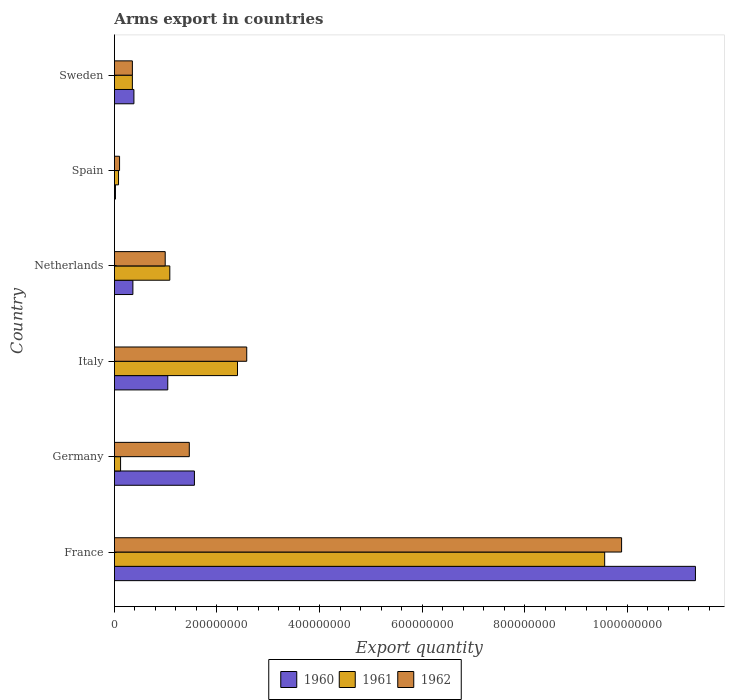How many different coloured bars are there?
Make the answer very short. 3. Are the number of bars on each tick of the Y-axis equal?
Your response must be concise. Yes. How many bars are there on the 3rd tick from the top?
Your answer should be compact. 3. How many bars are there on the 5th tick from the bottom?
Give a very brief answer. 3. In how many cases, is the number of bars for a given country not equal to the number of legend labels?
Provide a succinct answer. 0. What is the total arms export in 1961 in France?
Offer a terse response. 9.56e+08. Across all countries, what is the maximum total arms export in 1960?
Keep it short and to the point. 1.13e+09. Across all countries, what is the minimum total arms export in 1960?
Ensure brevity in your answer.  2.00e+06. In which country was the total arms export in 1962 minimum?
Offer a very short reply. Spain. What is the total total arms export in 1961 in the graph?
Your answer should be very brief. 1.36e+09. What is the difference between the total arms export in 1960 in France and that in Spain?
Offer a terse response. 1.13e+09. What is the difference between the total arms export in 1960 in Germany and the total arms export in 1961 in Sweden?
Provide a succinct answer. 1.21e+08. What is the average total arms export in 1962 per country?
Your answer should be compact. 2.56e+08. What is the difference between the total arms export in 1961 and total arms export in 1962 in France?
Offer a very short reply. -3.30e+07. In how many countries, is the total arms export in 1961 greater than 800000000 ?
Make the answer very short. 1. What is the ratio of the total arms export in 1962 in France to that in Netherlands?
Provide a succinct answer. 9.99. Is the difference between the total arms export in 1961 in France and Sweden greater than the difference between the total arms export in 1962 in France and Sweden?
Give a very brief answer. No. What is the difference between the highest and the second highest total arms export in 1961?
Your answer should be very brief. 7.16e+08. What is the difference between the highest and the lowest total arms export in 1962?
Make the answer very short. 9.79e+08. What does the 2nd bar from the top in Netherlands represents?
Offer a terse response. 1961. Are all the bars in the graph horizontal?
Provide a short and direct response. Yes. Are the values on the major ticks of X-axis written in scientific E-notation?
Make the answer very short. No. Does the graph contain any zero values?
Provide a short and direct response. No. Does the graph contain grids?
Give a very brief answer. No. Where does the legend appear in the graph?
Your answer should be very brief. Bottom center. How many legend labels are there?
Give a very brief answer. 3. What is the title of the graph?
Keep it short and to the point. Arms export in countries. What is the label or title of the X-axis?
Ensure brevity in your answer.  Export quantity. What is the label or title of the Y-axis?
Provide a short and direct response. Country. What is the Export quantity of 1960 in France?
Your response must be concise. 1.13e+09. What is the Export quantity in 1961 in France?
Offer a terse response. 9.56e+08. What is the Export quantity of 1962 in France?
Offer a terse response. 9.89e+08. What is the Export quantity in 1960 in Germany?
Make the answer very short. 1.56e+08. What is the Export quantity of 1961 in Germany?
Provide a short and direct response. 1.20e+07. What is the Export quantity of 1962 in Germany?
Your response must be concise. 1.46e+08. What is the Export quantity in 1960 in Italy?
Your answer should be compact. 1.04e+08. What is the Export quantity of 1961 in Italy?
Offer a terse response. 2.40e+08. What is the Export quantity in 1962 in Italy?
Make the answer very short. 2.58e+08. What is the Export quantity of 1960 in Netherlands?
Ensure brevity in your answer.  3.60e+07. What is the Export quantity in 1961 in Netherlands?
Your answer should be very brief. 1.08e+08. What is the Export quantity in 1962 in Netherlands?
Offer a very short reply. 9.90e+07. What is the Export quantity of 1960 in Spain?
Ensure brevity in your answer.  2.00e+06. What is the Export quantity of 1961 in Spain?
Your response must be concise. 8.00e+06. What is the Export quantity of 1962 in Spain?
Ensure brevity in your answer.  1.00e+07. What is the Export quantity in 1960 in Sweden?
Offer a terse response. 3.80e+07. What is the Export quantity in 1961 in Sweden?
Offer a terse response. 3.50e+07. What is the Export quantity of 1962 in Sweden?
Keep it short and to the point. 3.50e+07. Across all countries, what is the maximum Export quantity in 1960?
Your answer should be compact. 1.13e+09. Across all countries, what is the maximum Export quantity of 1961?
Provide a short and direct response. 9.56e+08. Across all countries, what is the maximum Export quantity in 1962?
Provide a short and direct response. 9.89e+08. Across all countries, what is the minimum Export quantity in 1960?
Provide a short and direct response. 2.00e+06. Across all countries, what is the minimum Export quantity of 1961?
Your answer should be compact. 8.00e+06. Across all countries, what is the minimum Export quantity in 1962?
Give a very brief answer. 1.00e+07. What is the total Export quantity in 1960 in the graph?
Provide a short and direct response. 1.47e+09. What is the total Export quantity of 1961 in the graph?
Offer a terse response. 1.36e+09. What is the total Export quantity of 1962 in the graph?
Provide a succinct answer. 1.54e+09. What is the difference between the Export quantity of 1960 in France and that in Germany?
Your answer should be compact. 9.77e+08. What is the difference between the Export quantity in 1961 in France and that in Germany?
Make the answer very short. 9.44e+08. What is the difference between the Export quantity in 1962 in France and that in Germany?
Ensure brevity in your answer.  8.43e+08. What is the difference between the Export quantity in 1960 in France and that in Italy?
Your answer should be very brief. 1.03e+09. What is the difference between the Export quantity in 1961 in France and that in Italy?
Provide a short and direct response. 7.16e+08. What is the difference between the Export quantity of 1962 in France and that in Italy?
Your response must be concise. 7.31e+08. What is the difference between the Export quantity of 1960 in France and that in Netherlands?
Provide a short and direct response. 1.10e+09. What is the difference between the Export quantity of 1961 in France and that in Netherlands?
Your answer should be very brief. 8.48e+08. What is the difference between the Export quantity of 1962 in France and that in Netherlands?
Your response must be concise. 8.90e+08. What is the difference between the Export quantity in 1960 in France and that in Spain?
Make the answer very short. 1.13e+09. What is the difference between the Export quantity of 1961 in France and that in Spain?
Give a very brief answer. 9.48e+08. What is the difference between the Export quantity of 1962 in France and that in Spain?
Your answer should be compact. 9.79e+08. What is the difference between the Export quantity of 1960 in France and that in Sweden?
Provide a succinct answer. 1.10e+09. What is the difference between the Export quantity in 1961 in France and that in Sweden?
Give a very brief answer. 9.21e+08. What is the difference between the Export quantity in 1962 in France and that in Sweden?
Ensure brevity in your answer.  9.54e+08. What is the difference between the Export quantity of 1960 in Germany and that in Italy?
Give a very brief answer. 5.20e+07. What is the difference between the Export quantity of 1961 in Germany and that in Italy?
Your response must be concise. -2.28e+08. What is the difference between the Export quantity in 1962 in Germany and that in Italy?
Make the answer very short. -1.12e+08. What is the difference between the Export quantity in 1960 in Germany and that in Netherlands?
Make the answer very short. 1.20e+08. What is the difference between the Export quantity of 1961 in Germany and that in Netherlands?
Provide a short and direct response. -9.60e+07. What is the difference between the Export quantity in 1962 in Germany and that in Netherlands?
Your answer should be very brief. 4.70e+07. What is the difference between the Export quantity of 1960 in Germany and that in Spain?
Your response must be concise. 1.54e+08. What is the difference between the Export quantity of 1961 in Germany and that in Spain?
Give a very brief answer. 4.00e+06. What is the difference between the Export quantity of 1962 in Germany and that in Spain?
Keep it short and to the point. 1.36e+08. What is the difference between the Export quantity in 1960 in Germany and that in Sweden?
Your response must be concise. 1.18e+08. What is the difference between the Export quantity in 1961 in Germany and that in Sweden?
Offer a very short reply. -2.30e+07. What is the difference between the Export quantity of 1962 in Germany and that in Sweden?
Your answer should be very brief. 1.11e+08. What is the difference between the Export quantity in 1960 in Italy and that in Netherlands?
Your response must be concise. 6.80e+07. What is the difference between the Export quantity in 1961 in Italy and that in Netherlands?
Provide a short and direct response. 1.32e+08. What is the difference between the Export quantity in 1962 in Italy and that in Netherlands?
Your response must be concise. 1.59e+08. What is the difference between the Export quantity in 1960 in Italy and that in Spain?
Ensure brevity in your answer.  1.02e+08. What is the difference between the Export quantity in 1961 in Italy and that in Spain?
Make the answer very short. 2.32e+08. What is the difference between the Export quantity of 1962 in Italy and that in Spain?
Your answer should be very brief. 2.48e+08. What is the difference between the Export quantity in 1960 in Italy and that in Sweden?
Your answer should be compact. 6.60e+07. What is the difference between the Export quantity in 1961 in Italy and that in Sweden?
Your answer should be compact. 2.05e+08. What is the difference between the Export quantity of 1962 in Italy and that in Sweden?
Provide a succinct answer. 2.23e+08. What is the difference between the Export quantity of 1960 in Netherlands and that in Spain?
Keep it short and to the point. 3.40e+07. What is the difference between the Export quantity in 1962 in Netherlands and that in Spain?
Offer a terse response. 8.90e+07. What is the difference between the Export quantity of 1960 in Netherlands and that in Sweden?
Your response must be concise. -2.00e+06. What is the difference between the Export quantity of 1961 in Netherlands and that in Sweden?
Make the answer very short. 7.30e+07. What is the difference between the Export quantity of 1962 in Netherlands and that in Sweden?
Your response must be concise. 6.40e+07. What is the difference between the Export quantity in 1960 in Spain and that in Sweden?
Give a very brief answer. -3.60e+07. What is the difference between the Export quantity in 1961 in Spain and that in Sweden?
Keep it short and to the point. -2.70e+07. What is the difference between the Export quantity in 1962 in Spain and that in Sweden?
Your answer should be compact. -2.50e+07. What is the difference between the Export quantity in 1960 in France and the Export quantity in 1961 in Germany?
Your answer should be very brief. 1.12e+09. What is the difference between the Export quantity of 1960 in France and the Export quantity of 1962 in Germany?
Your answer should be very brief. 9.87e+08. What is the difference between the Export quantity in 1961 in France and the Export quantity in 1962 in Germany?
Your answer should be compact. 8.10e+08. What is the difference between the Export quantity in 1960 in France and the Export quantity in 1961 in Italy?
Provide a short and direct response. 8.93e+08. What is the difference between the Export quantity in 1960 in France and the Export quantity in 1962 in Italy?
Your response must be concise. 8.75e+08. What is the difference between the Export quantity of 1961 in France and the Export quantity of 1962 in Italy?
Offer a very short reply. 6.98e+08. What is the difference between the Export quantity in 1960 in France and the Export quantity in 1961 in Netherlands?
Offer a very short reply. 1.02e+09. What is the difference between the Export quantity of 1960 in France and the Export quantity of 1962 in Netherlands?
Give a very brief answer. 1.03e+09. What is the difference between the Export quantity in 1961 in France and the Export quantity in 1962 in Netherlands?
Give a very brief answer. 8.57e+08. What is the difference between the Export quantity in 1960 in France and the Export quantity in 1961 in Spain?
Your answer should be compact. 1.12e+09. What is the difference between the Export quantity in 1960 in France and the Export quantity in 1962 in Spain?
Ensure brevity in your answer.  1.12e+09. What is the difference between the Export quantity in 1961 in France and the Export quantity in 1962 in Spain?
Your response must be concise. 9.46e+08. What is the difference between the Export quantity of 1960 in France and the Export quantity of 1961 in Sweden?
Keep it short and to the point. 1.10e+09. What is the difference between the Export quantity of 1960 in France and the Export quantity of 1962 in Sweden?
Your answer should be compact. 1.10e+09. What is the difference between the Export quantity of 1961 in France and the Export quantity of 1962 in Sweden?
Provide a short and direct response. 9.21e+08. What is the difference between the Export quantity of 1960 in Germany and the Export quantity of 1961 in Italy?
Your answer should be compact. -8.40e+07. What is the difference between the Export quantity of 1960 in Germany and the Export quantity of 1962 in Italy?
Give a very brief answer. -1.02e+08. What is the difference between the Export quantity in 1961 in Germany and the Export quantity in 1962 in Italy?
Keep it short and to the point. -2.46e+08. What is the difference between the Export quantity in 1960 in Germany and the Export quantity in 1961 in Netherlands?
Keep it short and to the point. 4.80e+07. What is the difference between the Export quantity in 1960 in Germany and the Export quantity in 1962 in Netherlands?
Offer a terse response. 5.70e+07. What is the difference between the Export quantity in 1961 in Germany and the Export quantity in 1962 in Netherlands?
Ensure brevity in your answer.  -8.70e+07. What is the difference between the Export quantity in 1960 in Germany and the Export quantity in 1961 in Spain?
Your answer should be compact. 1.48e+08. What is the difference between the Export quantity in 1960 in Germany and the Export quantity in 1962 in Spain?
Provide a short and direct response. 1.46e+08. What is the difference between the Export quantity in 1960 in Germany and the Export quantity in 1961 in Sweden?
Your answer should be very brief. 1.21e+08. What is the difference between the Export quantity in 1960 in Germany and the Export quantity in 1962 in Sweden?
Ensure brevity in your answer.  1.21e+08. What is the difference between the Export quantity in 1961 in Germany and the Export quantity in 1962 in Sweden?
Offer a very short reply. -2.30e+07. What is the difference between the Export quantity of 1960 in Italy and the Export quantity of 1961 in Netherlands?
Your response must be concise. -4.00e+06. What is the difference between the Export quantity of 1961 in Italy and the Export quantity of 1962 in Netherlands?
Ensure brevity in your answer.  1.41e+08. What is the difference between the Export quantity of 1960 in Italy and the Export quantity of 1961 in Spain?
Make the answer very short. 9.60e+07. What is the difference between the Export quantity of 1960 in Italy and the Export quantity of 1962 in Spain?
Your answer should be compact. 9.40e+07. What is the difference between the Export quantity in 1961 in Italy and the Export quantity in 1962 in Spain?
Ensure brevity in your answer.  2.30e+08. What is the difference between the Export quantity of 1960 in Italy and the Export quantity of 1961 in Sweden?
Make the answer very short. 6.90e+07. What is the difference between the Export quantity in 1960 in Italy and the Export quantity in 1962 in Sweden?
Offer a very short reply. 6.90e+07. What is the difference between the Export quantity in 1961 in Italy and the Export quantity in 1962 in Sweden?
Offer a very short reply. 2.05e+08. What is the difference between the Export quantity in 1960 in Netherlands and the Export quantity in 1961 in Spain?
Offer a very short reply. 2.80e+07. What is the difference between the Export quantity in 1960 in Netherlands and the Export quantity in 1962 in Spain?
Your answer should be very brief. 2.60e+07. What is the difference between the Export quantity in 1961 in Netherlands and the Export quantity in 1962 in Spain?
Provide a succinct answer. 9.80e+07. What is the difference between the Export quantity in 1960 in Netherlands and the Export quantity in 1961 in Sweden?
Keep it short and to the point. 1.00e+06. What is the difference between the Export quantity of 1961 in Netherlands and the Export quantity of 1962 in Sweden?
Keep it short and to the point. 7.30e+07. What is the difference between the Export quantity in 1960 in Spain and the Export quantity in 1961 in Sweden?
Make the answer very short. -3.30e+07. What is the difference between the Export quantity of 1960 in Spain and the Export quantity of 1962 in Sweden?
Your response must be concise. -3.30e+07. What is the difference between the Export quantity of 1961 in Spain and the Export quantity of 1962 in Sweden?
Provide a short and direct response. -2.70e+07. What is the average Export quantity in 1960 per country?
Provide a short and direct response. 2.45e+08. What is the average Export quantity of 1961 per country?
Your answer should be compact. 2.26e+08. What is the average Export quantity in 1962 per country?
Offer a very short reply. 2.56e+08. What is the difference between the Export quantity in 1960 and Export quantity in 1961 in France?
Your response must be concise. 1.77e+08. What is the difference between the Export quantity in 1960 and Export quantity in 1962 in France?
Ensure brevity in your answer.  1.44e+08. What is the difference between the Export quantity in 1961 and Export quantity in 1962 in France?
Your answer should be compact. -3.30e+07. What is the difference between the Export quantity of 1960 and Export quantity of 1961 in Germany?
Ensure brevity in your answer.  1.44e+08. What is the difference between the Export quantity of 1961 and Export quantity of 1962 in Germany?
Make the answer very short. -1.34e+08. What is the difference between the Export quantity in 1960 and Export quantity in 1961 in Italy?
Your response must be concise. -1.36e+08. What is the difference between the Export quantity in 1960 and Export quantity in 1962 in Italy?
Give a very brief answer. -1.54e+08. What is the difference between the Export quantity in 1961 and Export quantity in 1962 in Italy?
Your response must be concise. -1.80e+07. What is the difference between the Export quantity of 1960 and Export quantity of 1961 in Netherlands?
Your response must be concise. -7.20e+07. What is the difference between the Export quantity of 1960 and Export quantity of 1962 in Netherlands?
Your answer should be very brief. -6.30e+07. What is the difference between the Export quantity of 1961 and Export quantity of 1962 in Netherlands?
Offer a very short reply. 9.00e+06. What is the difference between the Export quantity of 1960 and Export quantity of 1961 in Spain?
Keep it short and to the point. -6.00e+06. What is the difference between the Export quantity of 1960 and Export quantity of 1962 in Spain?
Offer a terse response. -8.00e+06. What is the difference between the Export quantity of 1960 and Export quantity of 1961 in Sweden?
Provide a succinct answer. 3.00e+06. What is the difference between the Export quantity in 1960 and Export quantity in 1962 in Sweden?
Ensure brevity in your answer.  3.00e+06. What is the difference between the Export quantity in 1961 and Export quantity in 1962 in Sweden?
Provide a short and direct response. 0. What is the ratio of the Export quantity of 1960 in France to that in Germany?
Make the answer very short. 7.26. What is the ratio of the Export quantity of 1961 in France to that in Germany?
Give a very brief answer. 79.67. What is the ratio of the Export quantity in 1962 in France to that in Germany?
Make the answer very short. 6.77. What is the ratio of the Export quantity of 1960 in France to that in Italy?
Ensure brevity in your answer.  10.89. What is the ratio of the Export quantity of 1961 in France to that in Italy?
Provide a succinct answer. 3.98. What is the ratio of the Export quantity of 1962 in France to that in Italy?
Offer a very short reply. 3.83. What is the ratio of the Export quantity of 1960 in France to that in Netherlands?
Your answer should be very brief. 31.47. What is the ratio of the Export quantity of 1961 in France to that in Netherlands?
Your response must be concise. 8.85. What is the ratio of the Export quantity in 1962 in France to that in Netherlands?
Ensure brevity in your answer.  9.99. What is the ratio of the Export quantity in 1960 in France to that in Spain?
Your answer should be very brief. 566.5. What is the ratio of the Export quantity in 1961 in France to that in Spain?
Your answer should be very brief. 119.5. What is the ratio of the Export quantity in 1962 in France to that in Spain?
Keep it short and to the point. 98.9. What is the ratio of the Export quantity in 1960 in France to that in Sweden?
Provide a succinct answer. 29.82. What is the ratio of the Export quantity of 1961 in France to that in Sweden?
Offer a very short reply. 27.31. What is the ratio of the Export quantity of 1962 in France to that in Sweden?
Your answer should be compact. 28.26. What is the ratio of the Export quantity of 1961 in Germany to that in Italy?
Your answer should be very brief. 0.05. What is the ratio of the Export quantity in 1962 in Germany to that in Italy?
Ensure brevity in your answer.  0.57. What is the ratio of the Export quantity of 1960 in Germany to that in Netherlands?
Ensure brevity in your answer.  4.33. What is the ratio of the Export quantity of 1962 in Germany to that in Netherlands?
Keep it short and to the point. 1.47. What is the ratio of the Export quantity in 1960 in Germany to that in Spain?
Give a very brief answer. 78. What is the ratio of the Export quantity of 1962 in Germany to that in Spain?
Keep it short and to the point. 14.6. What is the ratio of the Export quantity in 1960 in Germany to that in Sweden?
Your answer should be compact. 4.11. What is the ratio of the Export quantity of 1961 in Germany to that in Sweden?
Keep it short and to the point. 0.34. What is the ratio of the Export quantity in 1962 in Germany to that in Sweden?
Provide a short and direct response. 4.17. What is the ratio of the Export quantity in 1960 in Italy to that in Netherlands?
Your answer should be very brief. 2.89. What is the ratio of the Export quantity of 1961 in Italy to that in Netherlands?
Your answer should be compact. 2.22. What is the ratio of the Export quantity in 1962 in Italy to that in Netherlands?
Make the answer very short. 2.61. What is the ratio of the Export quantity of 1961 in Italy to that in Spain?
Make the answer very short. 30. What is the ratio of the Export quantity in 1962 in Italy to that in Spain?
Keep it short and to the point. 25.8. What is the ratio of the Export quantity in 1960 in Italy to that in Sweden?
Your answer should be compact. 2.74. What is the ratio of the Export quantity of 1961 in Italy to that in Sweden?
Offer a very short reply. 6.86. What is the ratio of the Export quantity of 1962 in Italy to that in Sweden?
Offer a very short reply. 7.37. What is the ratio of the Export quantity of 1960 in Netherlands to that in Spain?
Offer a very short reply. 18. What is the ratio of the Export quantity of 1961 in Netherlands to that in Sweden?
Offer a very short reply. 3.09. What is the ratio of the Export quantity in 1962 in Netherlands to that in Sweden?
Provide a short and direct response. 2.83. What is the ratio of the Export quantity of 1960 in Spain to that in Sweden?
Make the answer very short. 0.05. What is the ratio of the Export quantity of 1961 in Spain to that in Sweden?
Keep it short and to the point. 0.23. What is the ratio of the Export quantity in 1962 in Spain to that in Sweden?
Provide a short and direct response. 0.29. What is the difference between the highest and the second highest Export quantity in 1960?
Provide a succinct answer. 9.77e+08. What is the difference between the highest and the second highest Export quantity in 1961?
Your answer should be compact. 7.16e+08. What is the difference between the highest and the second highest Export quantity of 1962?
Your answer should be compact. 7.31e+08. What is the difference between the highest and the lowest Export quantity of 1960?
Provide a succinct answer. 1.13e+09. What is the difference between the highest and the lowest Export quantity of 1961?
Provide a short and direct response. 9.48e+08. What is the difference between the highest and the lowest Export quantity in 1962?
Ensure brevity in your answer.  9.79e+08. 